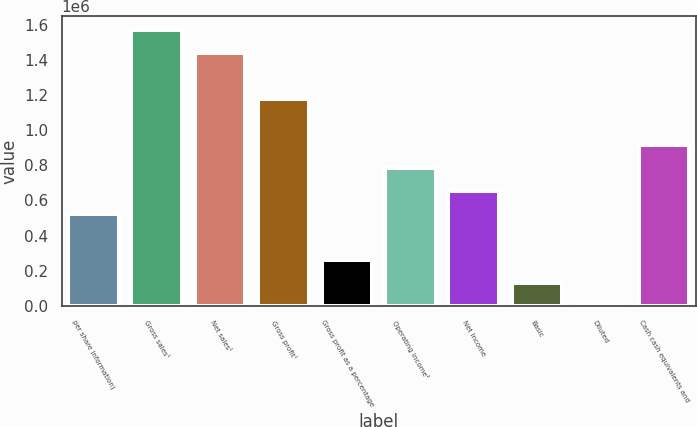Convert chart. <chart><loc_0><loc_0><loc_500><loc_500><bar_chart><fcel>per share information)<fcel>Gross sales¹<fcel>Net sales¹<fcel>Gross profit¹<fcel>Gross profit as a percentage<fcel>Operating income²<fcel>Net income<fcel>Basic<fcel>Diluted<fcel>Cash cash equivalents and<nl><fcel>523735<fcel>1.5712e+06<fcel>1.44027e+06<fcel>1.1784e+06<fcel>261869<fcel>785602<fcel>654669<fcel>130935<fcel>2.21<fcel>916535<nl></chart> 